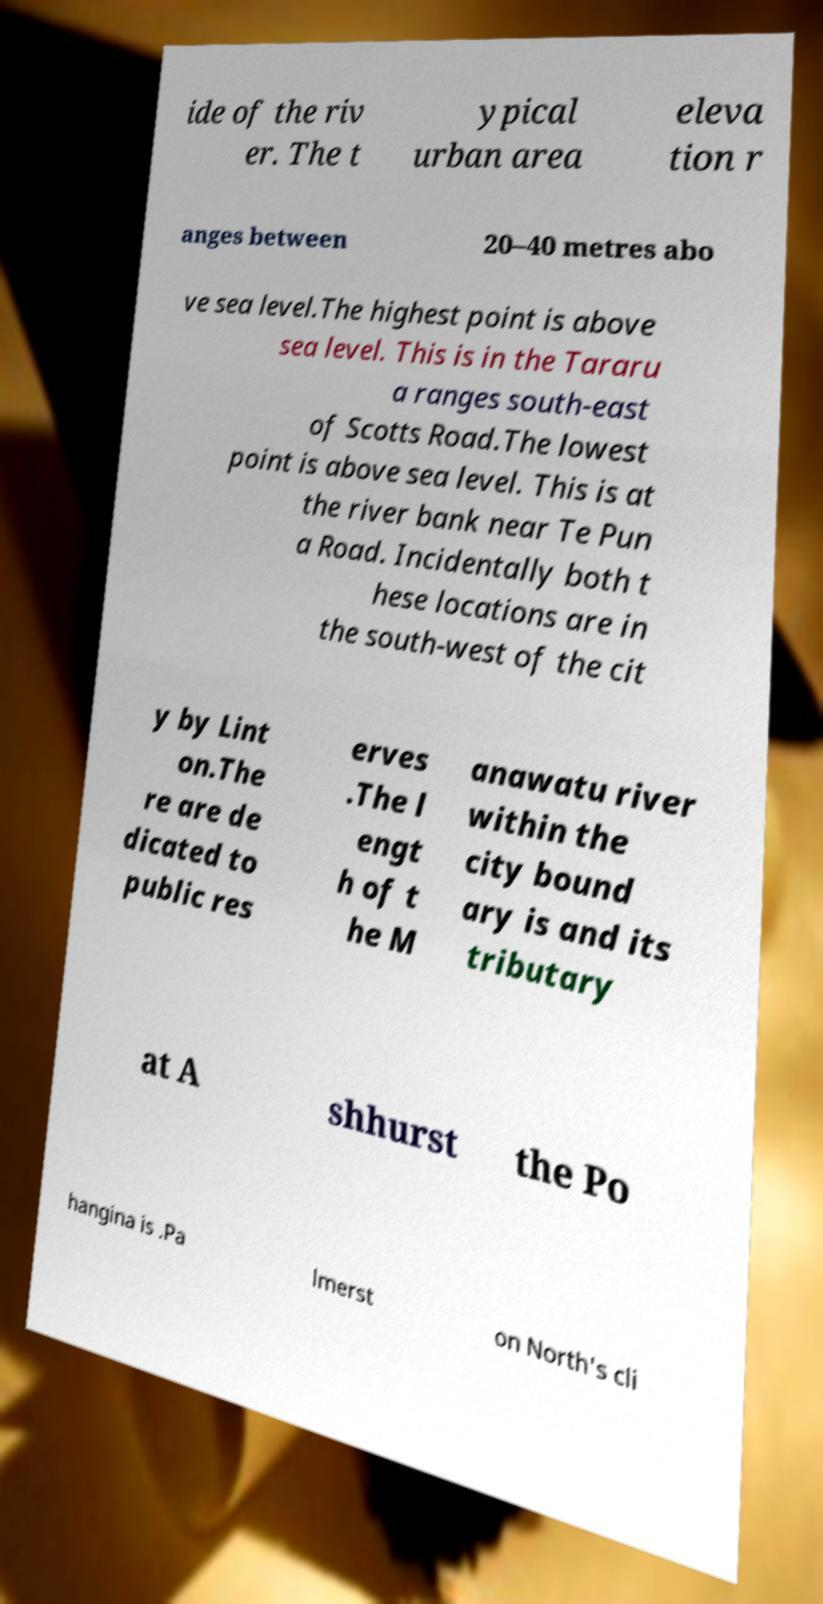Please identify and transcribe the text found in this image. ide of the riv er. The t ypical urban area eleva tion r anges between 20–40 metres abo ve sea level.The highest point is above sea level. This is in the Tararu a ranges south-east of Scotts Road.The lowest point is above sea level. This is at the river bank near Te Pun a Road. Incidentally both t hese locations are in the south-west of the cit y by Lint on.The re are de dicated to public res erves .The l engt h of t he M anawatu river within the city bound ary is and its tributary at A shhurst the Po hangina is .Pa lmerst on North's cli 